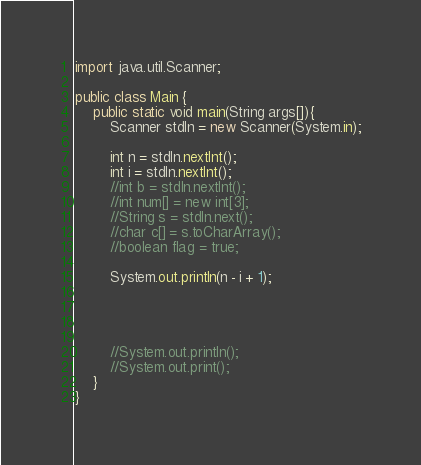<code> <loc_0><loc_0><loc_500><loc_500><_Java_>import java.util.Scanner;

public class Main {
    public static void main(String args[]){
        Scanner stdIn = new Scanner(System.in);
        
        int n = stdIn.nextInt();
        int i = stdIn.nextInt();
        //int b = stdIn.nextInt();
        //int num[] = new int[3];
        //String s = stdIn.next();
        //char c[] = s.toCharArray();
        //boolean flag = true;
        
        System.out.println(n - i + 1);
        
        
        
        
        //System.out.println();
        //System.out.print();
    }
}
</code> 